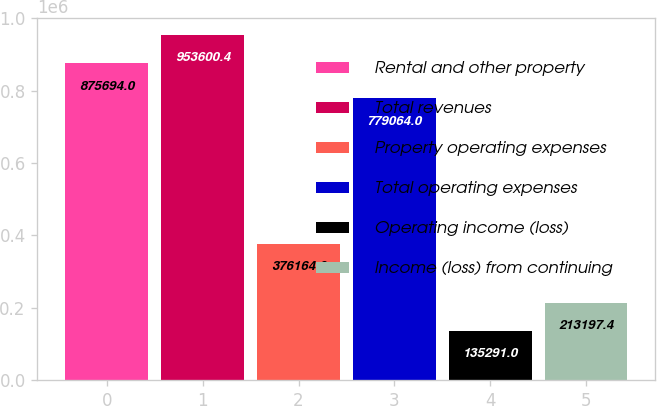Convert chart to OTSL. <chart><loc_0><loc_0><loc_500><loc_500><bar_chart><fcel>Rental and other property<fcel>Total revenues<fcel>Property operating expenses<fcel>Total operating expenses<fcel>Operating income (loss)<fcel>Income (loss) from continuing<nl><fcel>875694<fcel>953600<fcel>376164<fcel>779064<fcel>135291<fcel>213197<nl></chart> 